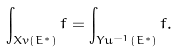Convert formula to latex. <formula><loc_0><loc_0><loc_500><loc_500>\int _ { X v ( E ^ { * } ) } f = \int _ { Y u ^ { - 1 } ( E ^ { * } ) } f .</formula> 